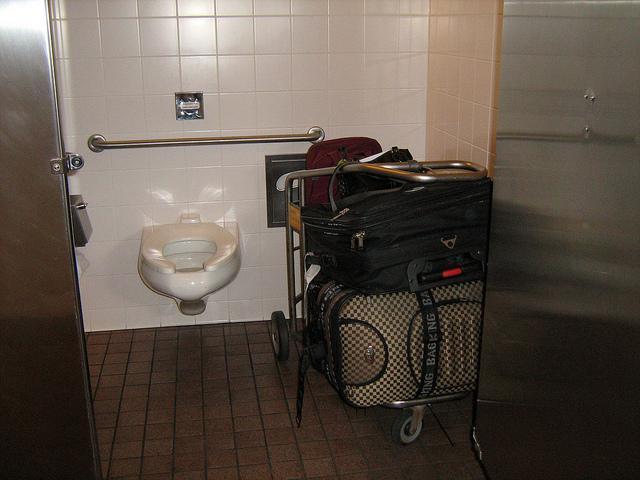How many toilets are there?
Give a very brief answer. 1. How many suitcases are in the photo?
Give a very brief answer. 2. How many toilets are visible?
Give a very brief answer. 1. How many chairs are shown around the table?
Give a very brief answer. 0. 